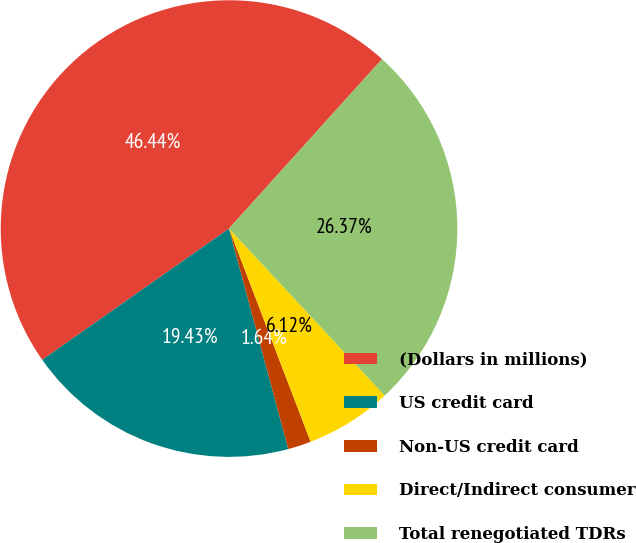Convert chart. <chart><loc_0><loc_0><loc_500><loc_500><pie_chart><fcel>(Dollars in millions)<fcel>US credit card<fcel>Non-US credit card<fcel>Direct/Indirect consumer<fcel>Total renegotiated TDRs<nl><fcel>46.44%<fcel>19.43%<fcel>1.64%<fcel>6.12%<fcel>26.37%<nl></chart> 